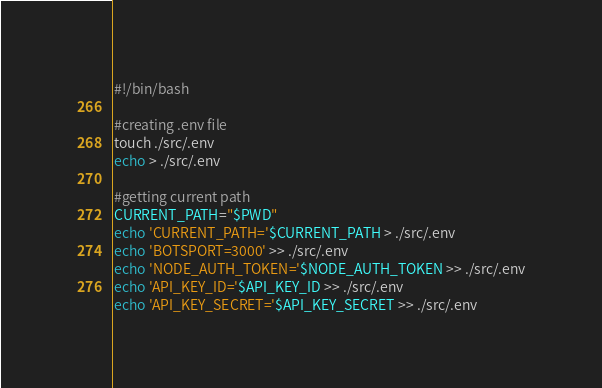Convert code to text. <code><loc_0><loc_0><loc_500><loc_500><_Bash_>#!/bin/bash

#creating .env file
touch ./src/.env
echo > ./src/.env

#getting current path
CURRENT_PATH="$PWD"
echo 'CURRENT_PATH='$CURRENT_PATH > ./src/.env
echo 'BOTSPORT=3000' >> ./src/.env
echo 'NODE_AUTH_TOKEN='$NODE_AUTH_TOKEN >> ./src/.env
echo 'API_KEY_ID='$API_KEY_ID >> ./src/.env
echo 'API_KEY_SECRET='$API_KEY_SECRET >> ./src/.env
</code> 